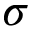<formula> <loc_0><loc_0><loc_500><loc_500>\sigma</formula> 